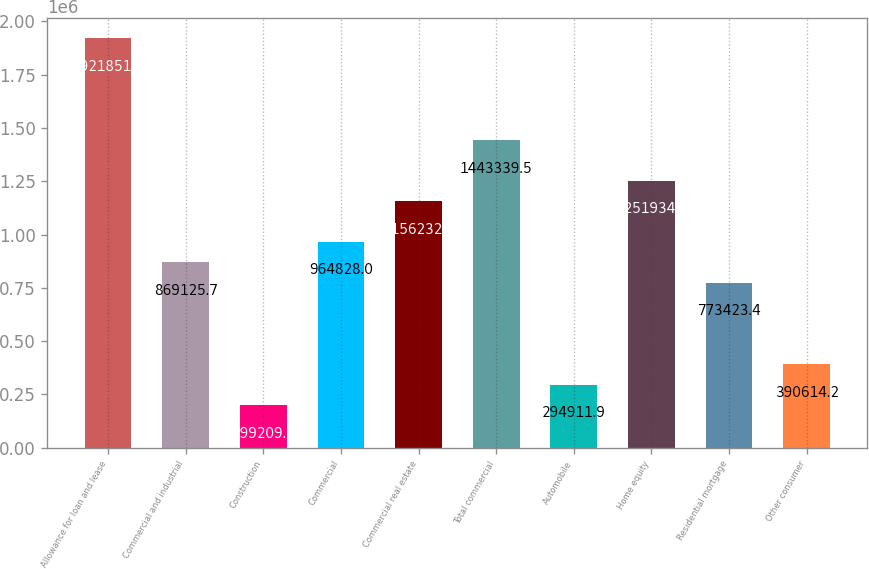<chart> <loc_0><loc_0><loc_500><loc_500><bar_chart><fcel>Allowance for loan and lease<fcel>Commercial and industrial<fcel>Construction<fcel>Commercial<fcel>Commercial real estate<fcel>Total commercial<fcel>Automobile<fcel>Home equity<fcel>Residential mortgage<fcel>Other consumer<nl><fcel>1.92185e+06<fcel>869126<fcel>199210<fcel>964828<fcel>1.15623e+06<fcel>1.44334e+06<fcel>294912<fcel>1.25193e+06<fcel>773423<fcel>390614<nl></chart> 